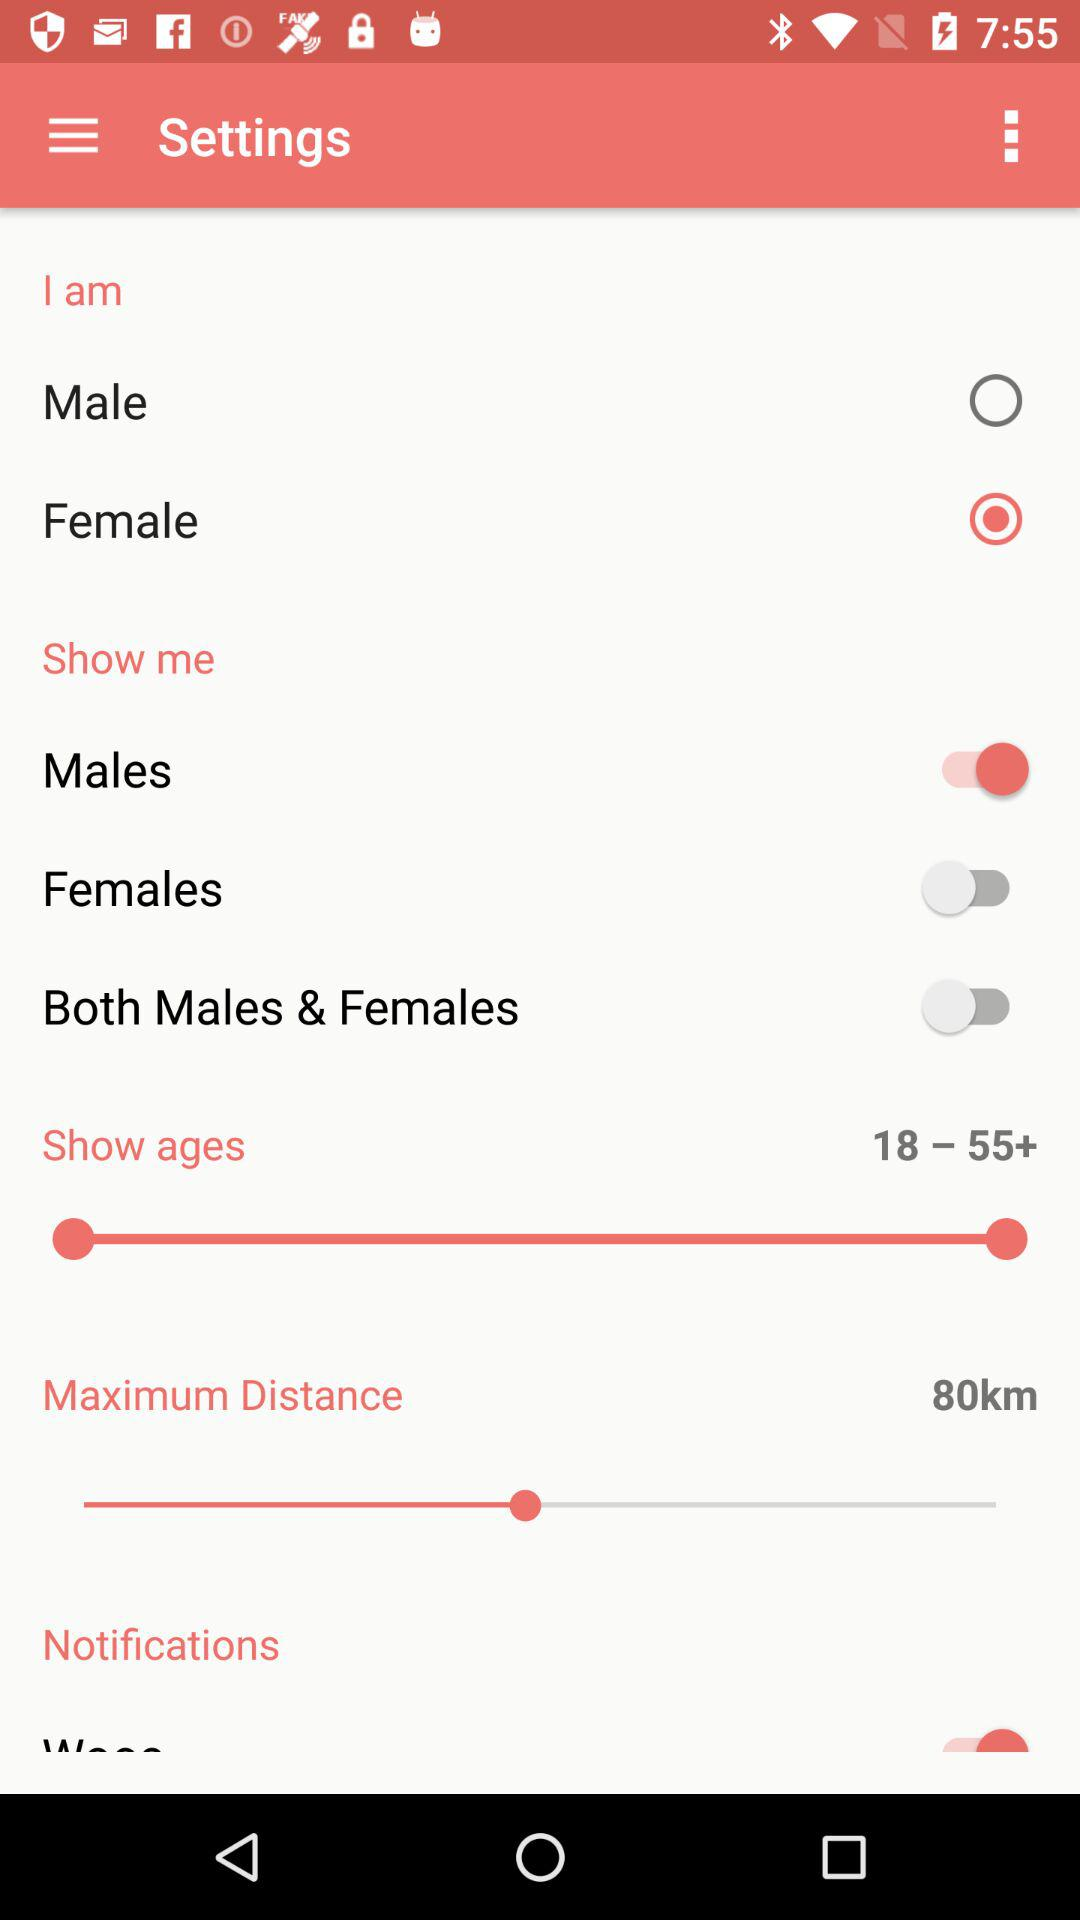What is the age limit? The age limit is from 18 to more than 55 years. 